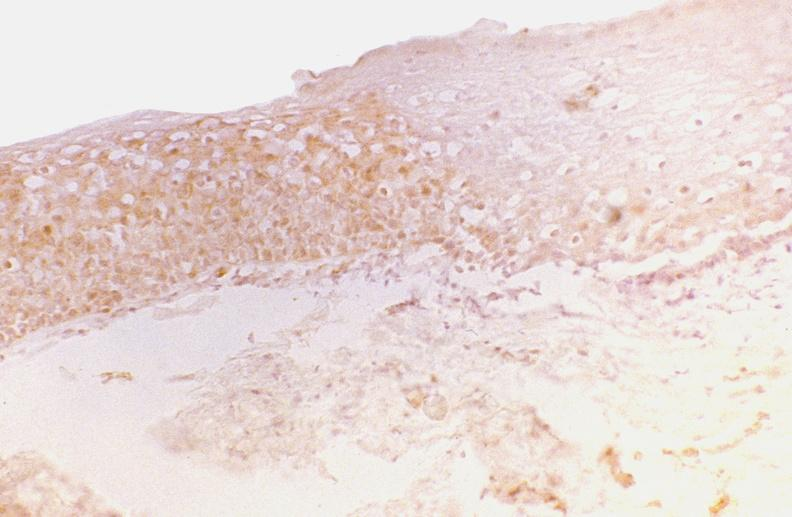s muscle atrophy present?
Answer the question using a single word or phrase. No 